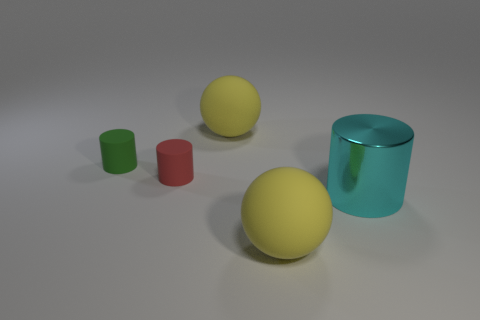Can you infer the possible material of the objects based on their appearance? Based on the objects' smooth surfaces and reflective qualities, they seem to be made of a material similar to plastic or polished metal, suggesting they are solid and relatively lightweight.  What is the relative position of the green sphere to the red cylinder? The green sphere is located to the right and slightly behind the small red cylinder from the perspective of the viewer. 